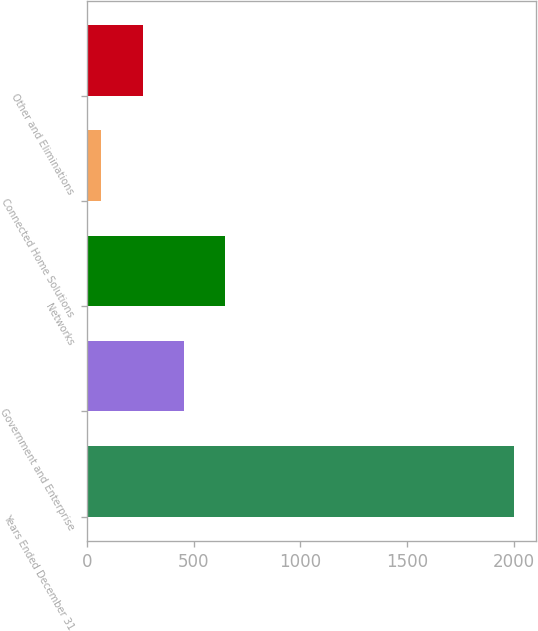Convert chart to OTSL. <chart><loc_0><loc_0><loc_500><loc_500><bar_chart><fcel>Years Ended December 31<fcel>Government and Enterprise<fcel>Networks<fcel>Connected Home Solutions<fcel>Other and Eliminations<nl><fcel>2003<fcel>453.4<fcel>647.1<fcel>66<fcel>259.7<nl></chart> 